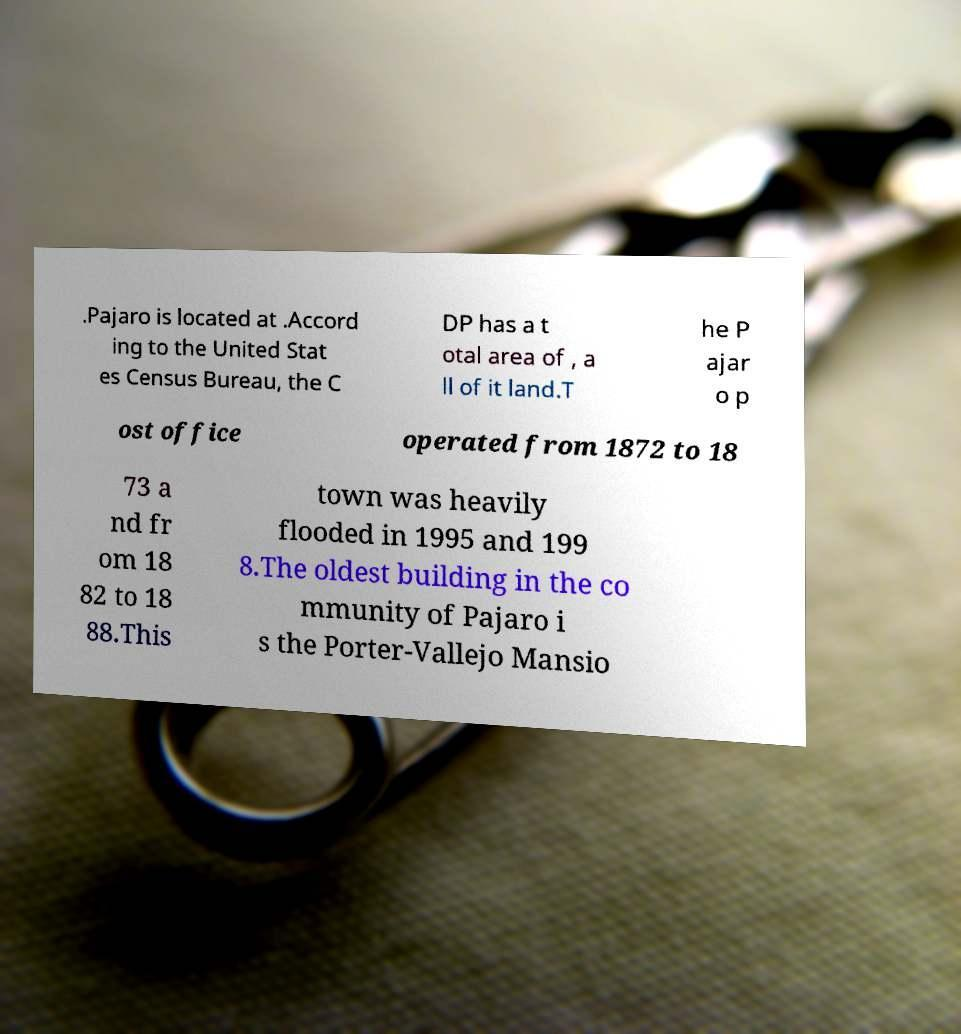Could you assist in decoding the text presented in this image and type it out clearly? .Pajaro is located at .Accord ing to the United Stat es Census Bureau, the C DP has a t otal area of , a ll of it land.T he P ajar o p ost office operated from 1872 to 18 73 a nd fr om 18 82 to 18 88.This town was heavily flooded in 1995 and 199 8.The oldest building in the co mmunity of Pajaro i s the Porter-Vallejo Mansio 